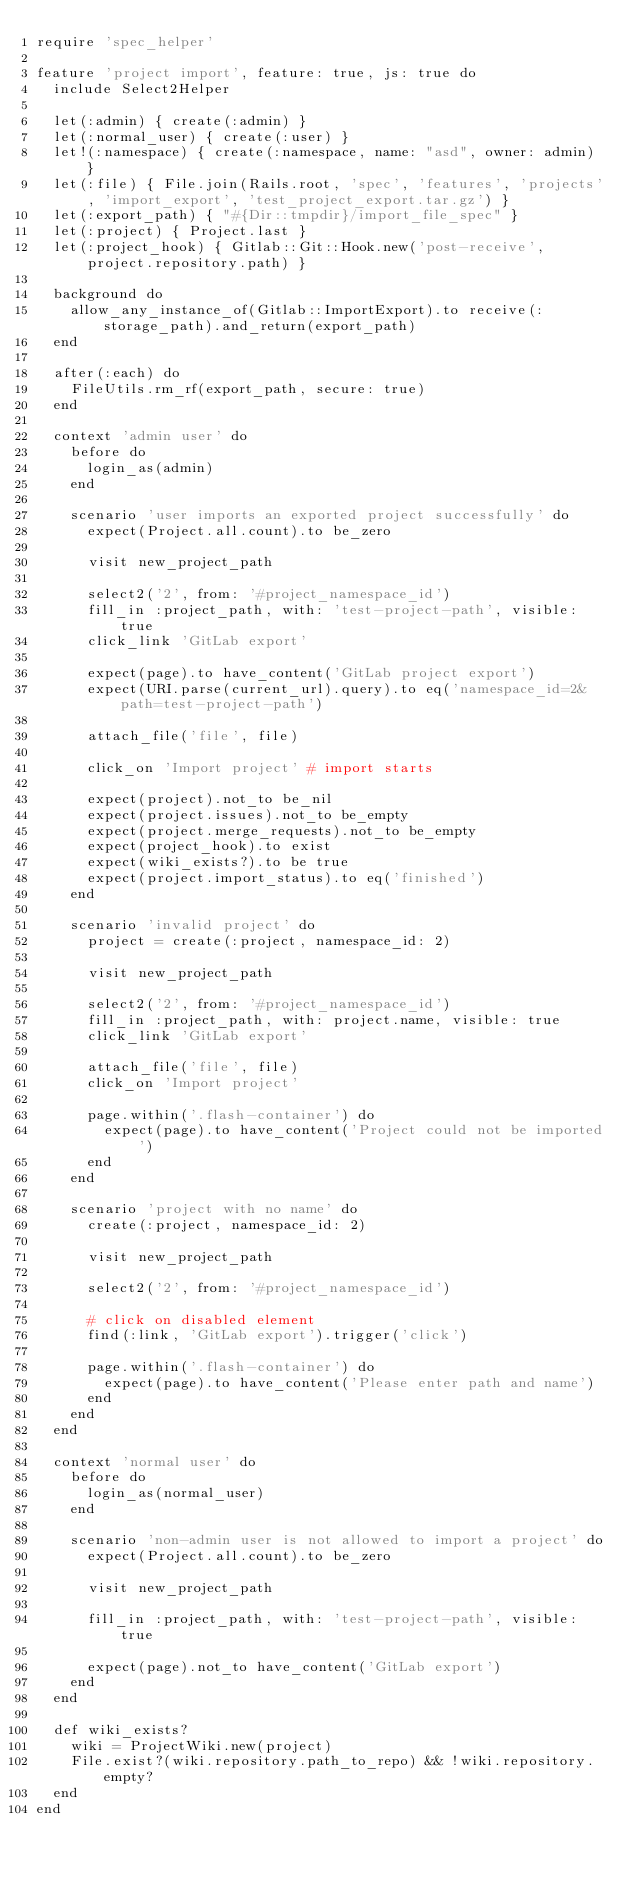Convert code to text. <code><loc_0><loc_0><loc_500><loc_500><_Ruby_>require 'spec_helper'

feature 'project import', feature: true, js: true do
  include Select2Helper

  let(:admin) { create(:admin) }
  let(:normal_user) { create(:user) }
  let!(:namespace) { create(:namespace, name: "asd", owner: admin) }
  let(:file) { File.join(Rails.root, 'spec', 'features', 'projects', 'import_export', 'test_project_export.tar.gz') }
  let(:export_path) { "#{Dir::tmpdir}/import_file_spec" }
  let(:project) { Project.last }
  let(:project_hook) { Gitlab::Git::Hook.new('post-receive', project.repository.path) }

  background do
    allow_any_instance_of(Gitlab::ImportExport).to receive(:storage_path).and_return(export_path)
  end

  after(:each) do
    FileUtils.rm_rf(export_path, secure: true)
  end

  context 'admin user' do
    before do
      login_as(admin)
    end

    scenario 'user imports an exported project successfully' do
      expect(Project.all.count).to be_zero

      visit new_project_path

      select2('2', from: '#project_namespace_id')
      fill_in :project_path, with: 'test-project-path', visible: true
      click_link 'GitLab export'

      expect(page).to have_content('GitLab project export')
      expect(URI.parse(current_url).query).to eq('namespace_id=2&path=test-project-path')

      attach_file('file', file)

      click_on 'Import project' # import starts

      expect(project).not_to be_nil
      expect(project.issues).not_to be_empty
      expect(project.merge_requests).not_to be_empty
      expect(project_hook).to exist
      expect(wiki_exists?).to be true
      expect(project.import_status).to eq('finished')
    end

    scenario 'invalid project' do
      project = create(:project, namespace_id: 2)

      visit new_project_path

      select2('2', from: '#project_namespace_id')
      fill_in :project_path, with: project.name, visible: true
      click_link 'GitLab export'

      attach_file('file', file)
      click_on 'Import project'

      page.within('.flash-container') do
        expect(page).to have_content('Project could not be imported')
      end
    end

    scenario 'project with no name' do
      create(:project, namespace_id: 2)

      visit new_project_path

      select2('2', from: '#project_namespace_id')

      # click on disabled element
      find(:link, 'GitLab export').trigger('click')

      page.within('.flash-container') do
        expect(page).to have_content('Please enter path and name')
      end
    end
  end

  context 'normal user' do
    before do
      login_as(normal_user)
    end

    scenario 'non-admin user is not allowed to import a project' do
      expect(Project.all.count).to be_zero

      visit new_project_path

      fill_in :project_path, with: 'test-project-path', visible: true

      expect(page).not_to have_content('GitLab export')
    end
  end

  def wiki_exists?
    wiki = ProjectWiki.new(project)
    File.exist?(wiki.repository.path_to_repo) && !wiki.repository.empty?
  end
end
</code> 